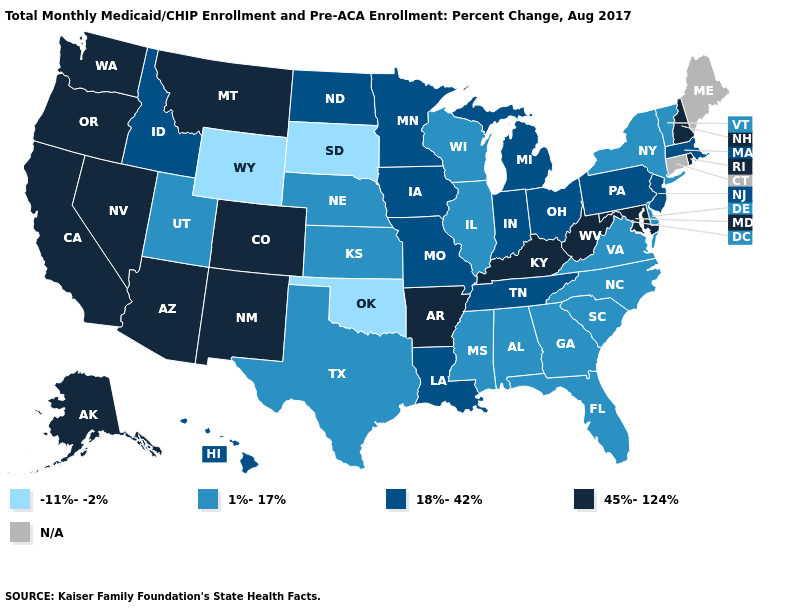Among the states that border Virginia , does North Carolina have the lowest value?
Answer briefly. Yes. Does Oklahoma have the highest value in the USA?
Concise answer only. No. Which states hav the highest value in the West?
Answer briefly. Alaska, Arizona, California, Colorado, Montana, Nevada, New Mexico, Oregon, Washington. What is the lowest value in the MidWest?
Concise answer only. -11%--2%. How many symbols are there in the legend?
Be succinct. 5. Does South Carolina have the highest value in the South?
Be succinct. No. Name the states that have a value in the range 18%-42%?
Keep it brief. Hawaii, Idaho, Indiana, Iowa, Louisiana, Massachusetts, Michigan, Minnesota, Missouri, New Jersey, North Dakota, Ohio, Pennsylvania, Tennessee. Does Rhode Island have the lowest value in the Northeast?
Quick response, please. No. How many symbols are there in the legend?
Give a very brief answer. 5. Among the states that border New Mexico , does Arizona have the highest value?
Write a very short answer. Yes. What is the highest value in the South ?
Short answer required. 45%-124%. What is the lowest value in the USA?
Be succinct. -11%--2%. Name the states that have a value in the range 45%-124%?
Be succinct. Alaska, Arizona, Arkansas, California, Colorado, Kentucky, Maryland, Montana, Nevada, New Hampshire, New Mexico, Oregon, Rhode Island, Washington, West Virginia. Does the map have missing data?
Quick response, please. Yes. 